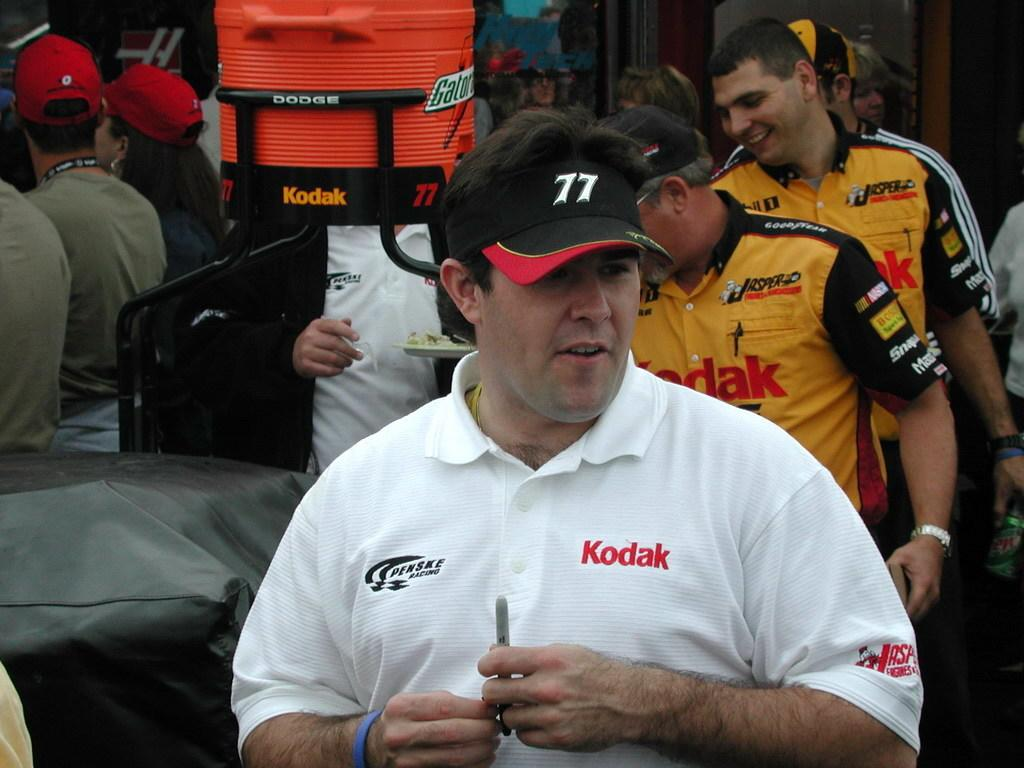<image>
Present a compact description of the photo's key features. Members of the Penske racing team line up behind a man in a white shirt and black cap. 